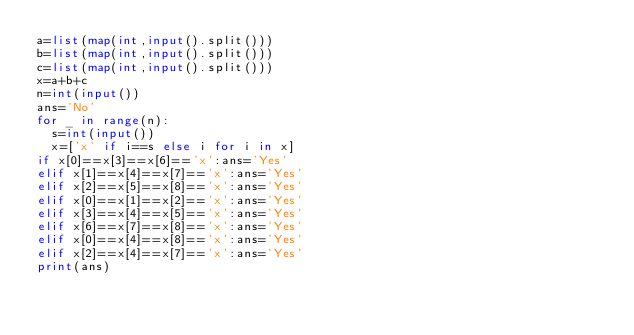<code> <loc_0><loc_0><loc_500><loc_500><_Python_>a=list(map(int,input().split()))
b=list(map(int,input().split()))
c=list(map(int,input().split()))
x=a+b+c
n=int(input())
ans='No'
for _ in range(n):
  s=int(input())
  x=['x' if i==s else i for i in x]
if x[0]==x[3]==x[6]=='x':ans='Yes'
elif x[1]==x[4]==x[7]=='x':ans='Yes'
elif x[2]==x[5]==x[8]=='x':ans='Yes'
elif x[0]==x[1]==x[2]=='x':ans='Yes'
elif x[3]==x[4]==x[5]=='x':ans='Yes'
elif x[6]==x[7]==x[8]=='x':ans='Yes'
elif x[0]==x[4]==x[8]=='x':ans='Yes'
elif x[2]==x[4]==x[7]=='x':ans='Yes'
print(ans)
</code> 